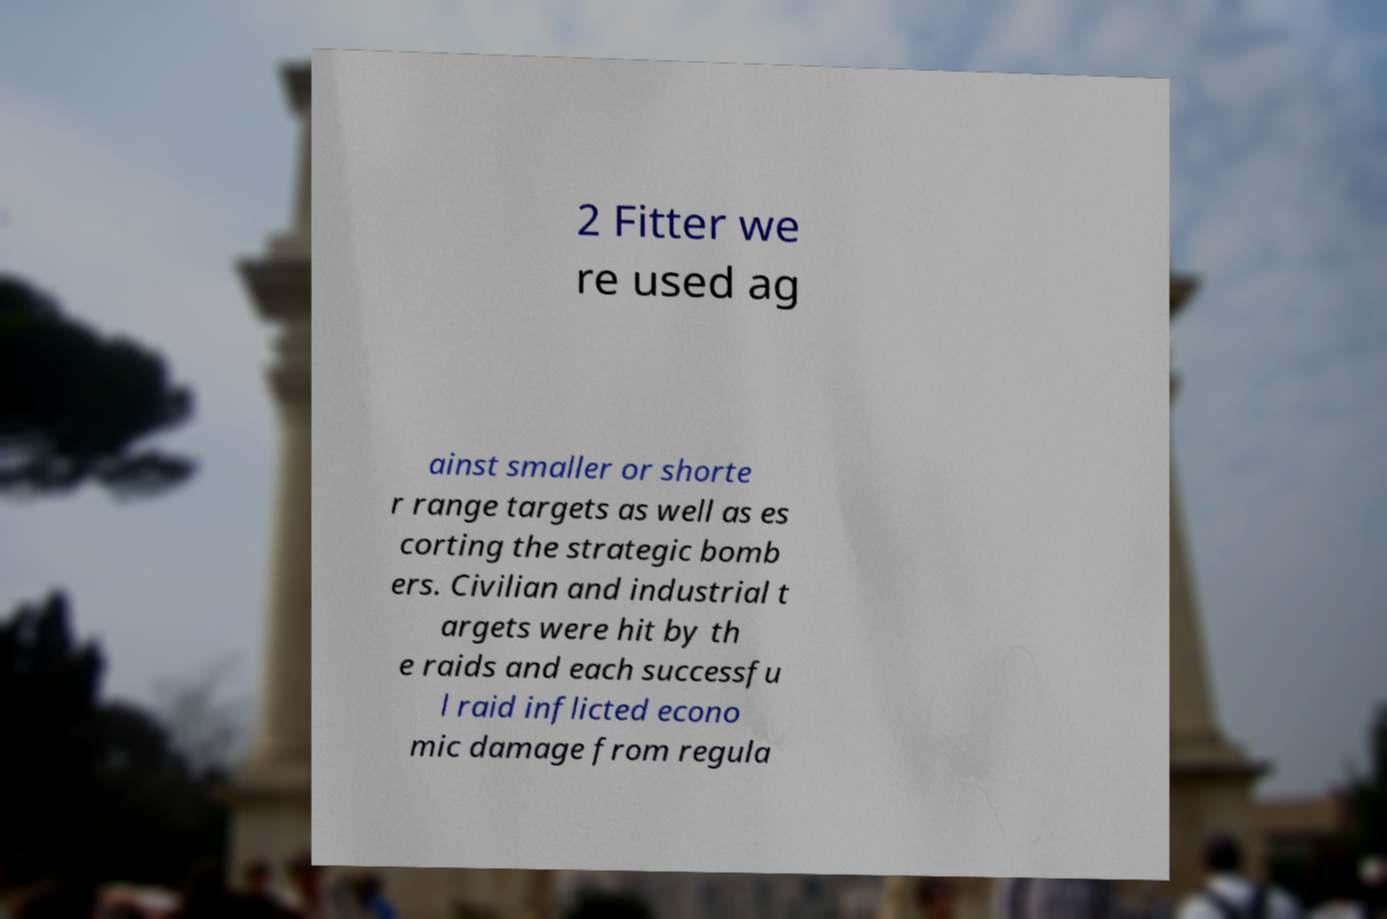Please read and relay the text visible in this image. What does it say? 2 Fitter we re used ag ainst smaller or shorte r range targets as well as es corting the strategic bomb ers. Civilian and industrial t argets were hit by th e raids and each successfu l raid inflicted econo mic damage from regula 